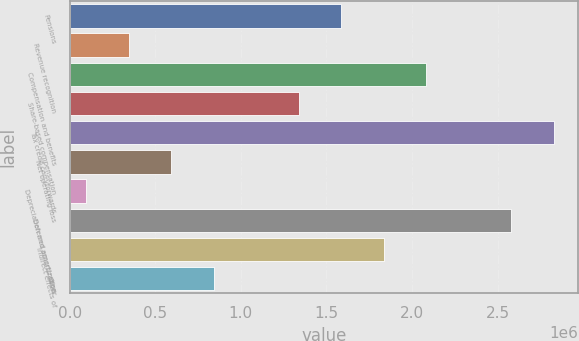Convert chart to OTSL. <chart><loc_0><loc_0><loc_500><loc_500><bar_chart><fcel>Pensions<fcel>Revenue recognition<fcel>Compensation and benefits<fcel>Share-based compensation<fcel>Tax credit carryforwards<fcel>Net operating loss<fcel>Depreciation and amortization<fcel>Deferred amortization<fcel>Indirect effects of<fcel>Other<nl><fcel>1.58727e+06<fcel>345560<fcel>2.08395e+06<fcel>1.33893e+06<fcel>2.82897e+06<fcel>593901<fcel>97218<fcel>2.58063e+06<fcel>1.83561e+06<fcel>842242<nl></chart> 